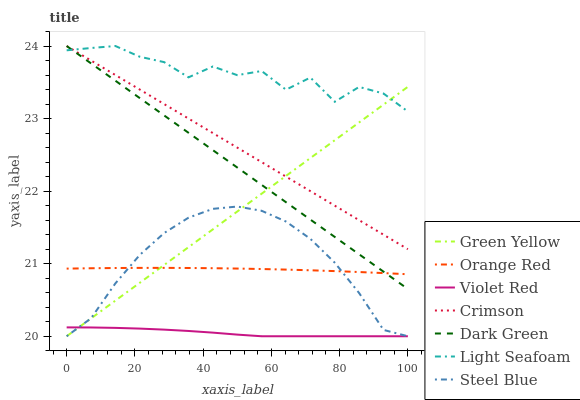Does Violet Red have the minimum area under the curve?
Answer yes or no. Yes. Does Light Seafoam have the maximum area under the curve?
Answer yes or no. Yes. Does Steel Blue have the minimum area under the curve?
Answer yes or no. No. Does Steel Blue have the maximum area under the curve?
Answer yes or no. No. Is Green Yellow the smoothest?
Answer yes or no. Yes. Is Light Seafoam the roughest?
Answer yes or no. Yes. Is Steel Blue the smoothest?
Answer yes or no. No. Is Steel Blue the roughest?
Answer yes or no. No. Does Violet Red have the lowest value?
Answer yes or no. Yes. Does Light Seafoam have the lowest value?
Answer yes or no. No. Does Dark Green have the highest value?
Answer yes or no. Yes. Does Steel Blue have the highest value?
Answer yes or no. No. Is Steel Blue less than Dark Green?
Answer yes or no. Yes. Is Crimson greater than Steel Blue?
Answer yes or no. Yes. Does Dark Green intersect Orange Red?
Answer yes or no. Yes. Is Dark Green less than Orange Red?
Answer yes or no. No. Is Dark Green greater than Orange Red?
Answer yes or no. No. Does Steel Blue intersect Dark Green?
Answer yes or no. No. 